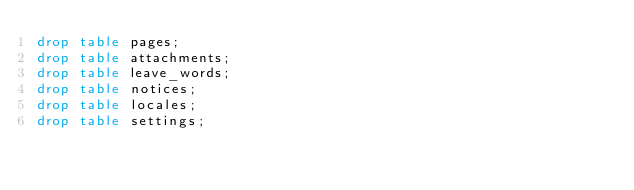Convert code to text. <code><loc_0><loc_0><loc_500><loc_500><_SQL_>drop table pages;
drop table attachments;
drop table leave_words;
drop table notices;
drop table locales;
drop table settings;
</code> 